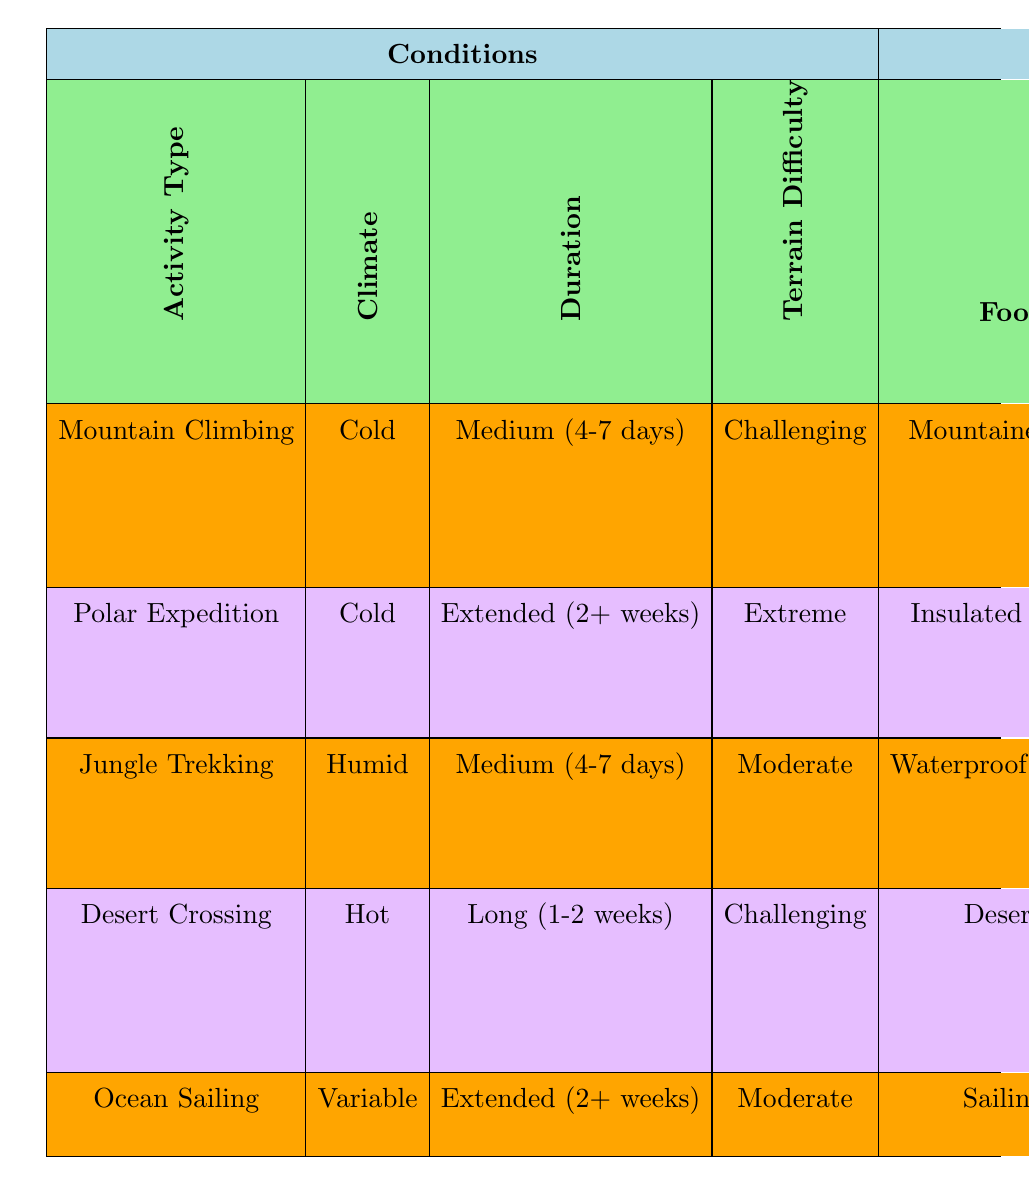What type of footwear is recommended for a Polar Expedition? By looking at the row for "Polar Expedition," we can see that the recommended footwear is "Insulated Snow Boots."
Answer: Insulated Snow Boots What is the outerwear used for Mountain Climbing in cold conditions? From the "Mountain Climbing" row where the climate is cold, the outerwear specified is "Down Jacket."
Answer: Down Jacket Is a GPS Device used in Jungle Trekking? In the row for "Jungle Trekking," navigation tools listed include "Compass," but not "GPS Device." Therefore, it’s false that a GPS Device is used in this activity.
Answer: No Which activity has the longest duration and what is the sleeping gear recommended? The "Polar Expedition" has the longest duration which is "Extended (2+ weeks)," and the corresponding sleeping gear is "Arctic Sleeping Bag."
Answer: Arctic Sleeping Bag Does Ocean Sailing require Ice Axe and Crampons for safety equipment? Checking the row for "Ocean Sailing," we find that the safety equipment is listed as "Life Jacket," not "Ice Axe and Crampons," making the statement false.
Answer: No For a Desert Crossing with challenging terrain, what type of navigation tools are used? Referring to the "Desert Crossing" row, the navigation tool listed is "GPS Device."
Answer: GPS Device What is the average duration across all activities listed? The activities provide various durations: Short (1-3 days), Medium (4-7 days), Long (1-2 weeks), and Extended (2+ weeks). In terms of approximate average terms, we can categorize and average them as follows: Short = 2 days, Medium = 5.5 days, Long = 10.5 days, Extended = 14 days. Therefore, calculating the average gives us (2 + 5.5 + 10.5 + 14) / 4 = 8.25 days.
Answer: 8.25 days What type of sleeping gear is needed for a Jungle Trekking activity? Looking at the row for "Jungle Trekking" under medium duration, the sleeping gear indicated is "Jungle Hammock."
Answer: Jungle Hammock Based on the table, is it true that all activities require specific outerwear? Each activity listed has a specification for outerwear, thus the statement is true.
Answer: Yes 